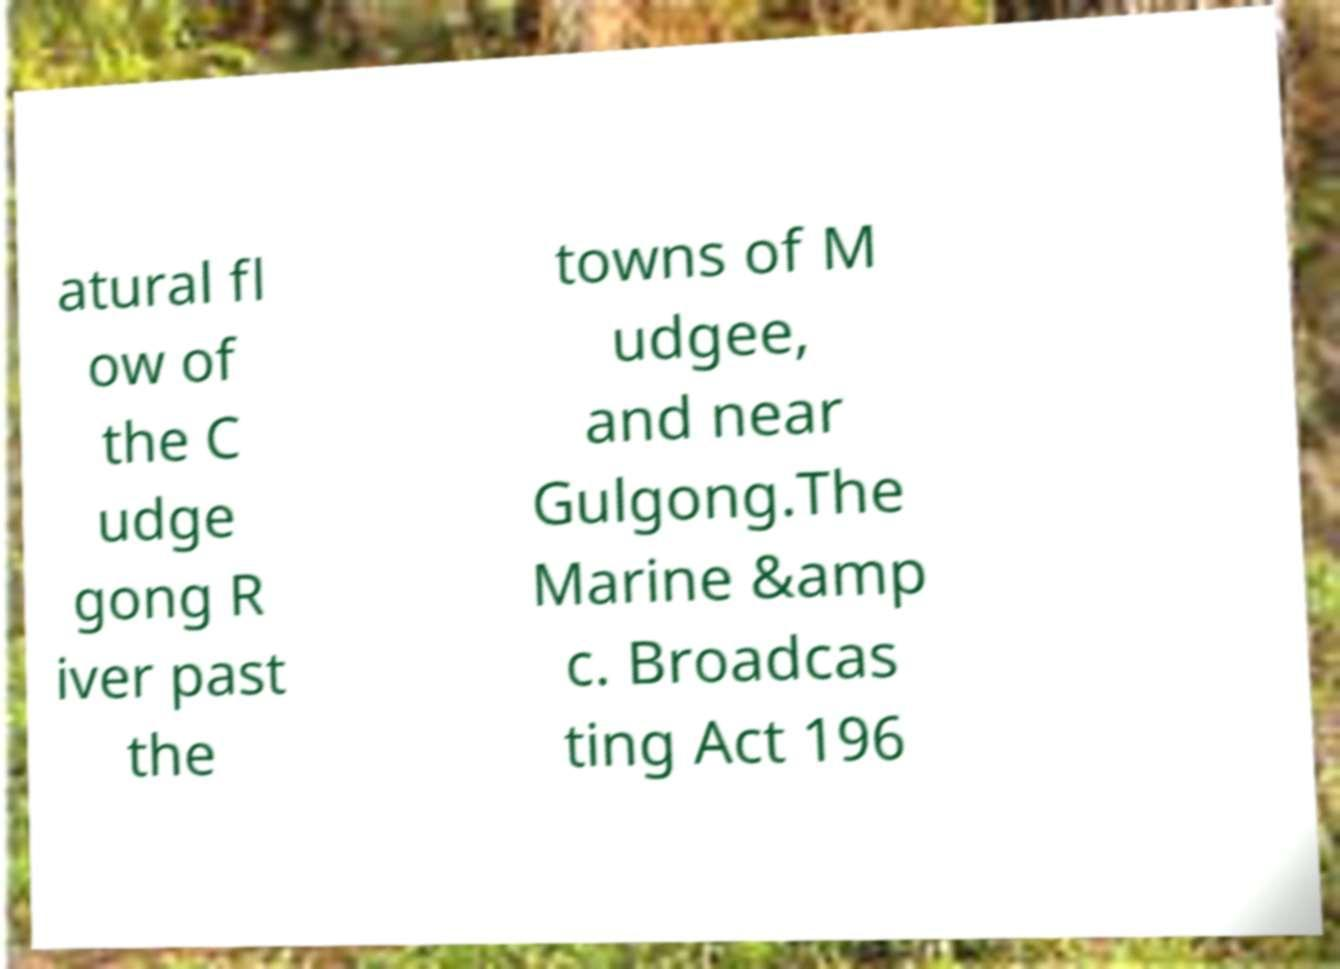Can you accurately transcribe the text from the provided image for me? atural fl ow of the C udge gong R iver past the towns of M udgee, and near Gulgong.The Marine &amp c. Broadcas ting Act 196 